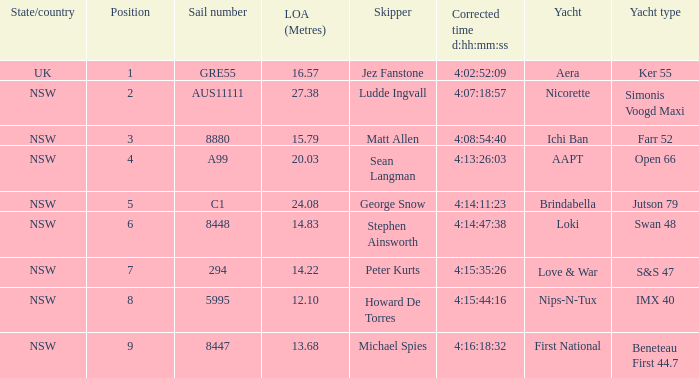What is the identifier for the sail measuring 13.68 in overall length? 8447.0. 